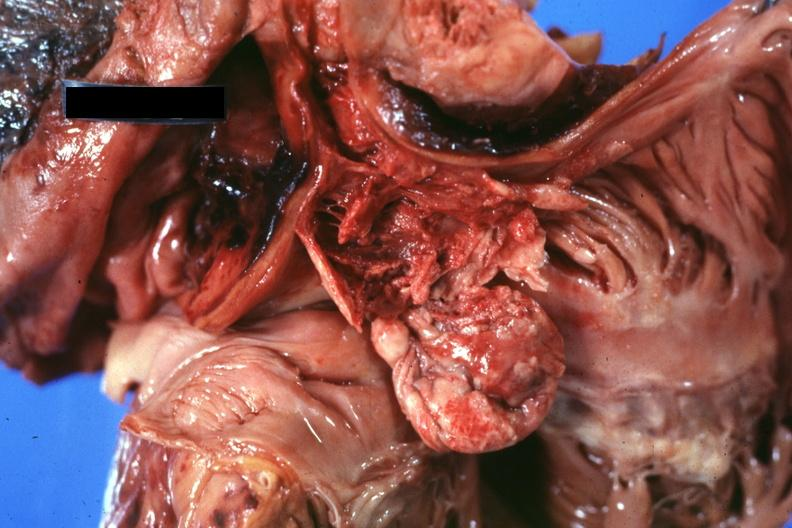s granulomata slide present?
Answer the question using a single word or phrase. No 